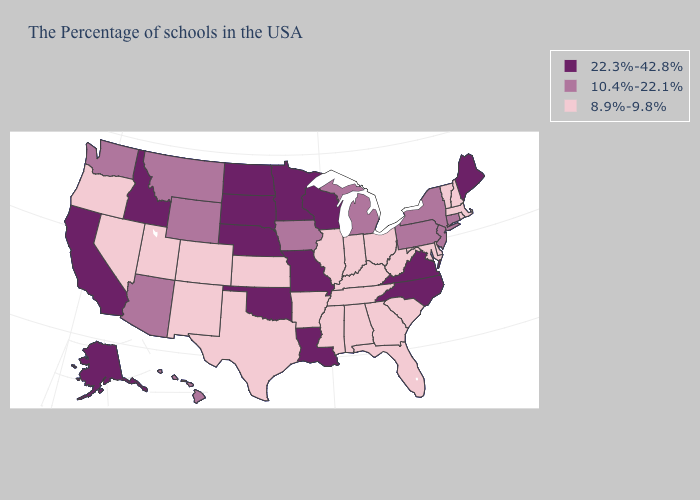Does the map have missing data?
Quick response, please. No. What is the highest value in the USA?
Be succinct. 22.3%-42.8%. Does Delaware have a lower value than Louisiana?
Concise answer only. Yes. What is the highest value in the USA?
Give a very brief answer. 22.3%-42.8%. Among the states that border New York , does Massachusetts have the highest value?
Keep it brief. No. Name the states that have a value in the range 22.3%-42.8%?
Keep it brief. Maine, Virginia, North Carolina, Wisconsin, Louisiana, Missouri, Minnesota, Nebraska, Oklahoma, South Dakota, North Dakota, Idaho, California, Alaska. What is the value of Oklahoma?
Write a very short answer. 22.3%-42.8%. What is the lowest value in states that border Michigan?
Be succinct. 8.9%-9.8%. What is the value of Maine?
Write a very short answer. 22.3%-42.8%. Does South Dakota have the lowest value in the USA?
Keep it brief. No. Among the states that border California , does Arizona have the lowest value?
Write a very short answer. No. Name the states that have a value in the range 22.3%-42.8%?
Give a very brief answer. Maine, Virginia, North Carolina, Wisconsin, Louisiana, Missouri, Minnesota, Nebraska, Oklahoma, South Dakota, North Dakota, Idaho, California, Alaska. Does Washington have the same value as Michigan?
Answer briefly. Yes. Name the states that have a value in the range 10.4%-22.1%?
Answer briefly. Connecticut, New York, New Jersey, Pennsylvania, Michigan, Iowa, Wyoming, Montana, Arizona, Washington, Hawaii. 